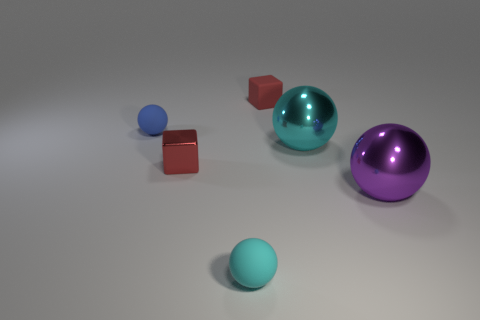Subtract 1 balls. How many balls are left? 3 Subtract all blue spheres. How many spheres are left? 3 Subtract all cyan shiny balls. How many balls are left? 3 Subtract all gray spheres. Subtract all red cylinders. How many spheres are left? 4 Add 3 red things. How many objects exist? 9 Subtract all blocks. How many objects are left? 4 Add 5 shiny cubes. How many shiny cubes exist? 6 Subtract 0 cyan blocks. How many objects are left? 6 Subtract all big purple matte cylinders. Subtract all balls. How many objects are left? 2 Add 4 tiny cyan balls. How many tiny cyan balls are left? 5 